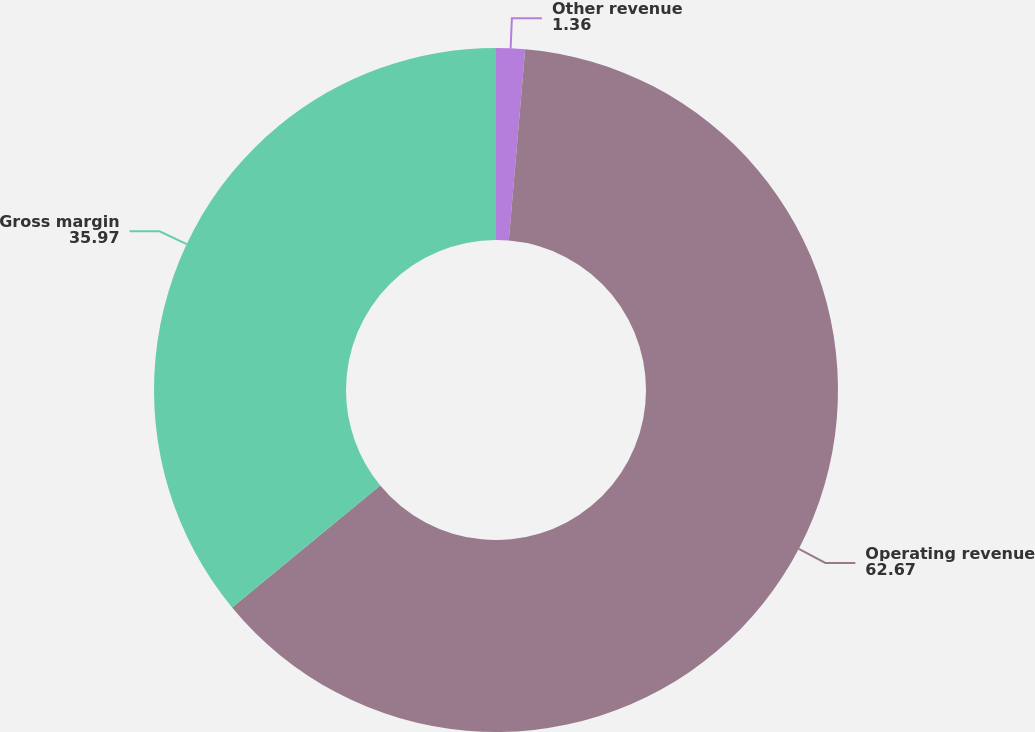Convert chart. <chart><loc_0><loc_0><loc_500><loc_500><pie_chart><fcel>Other revenue<fcel>Operating revenue<fcel>Gross margin<nl><fcel>1.36%<fcel>62.67%<fcel>35.97%<nl></chart> 